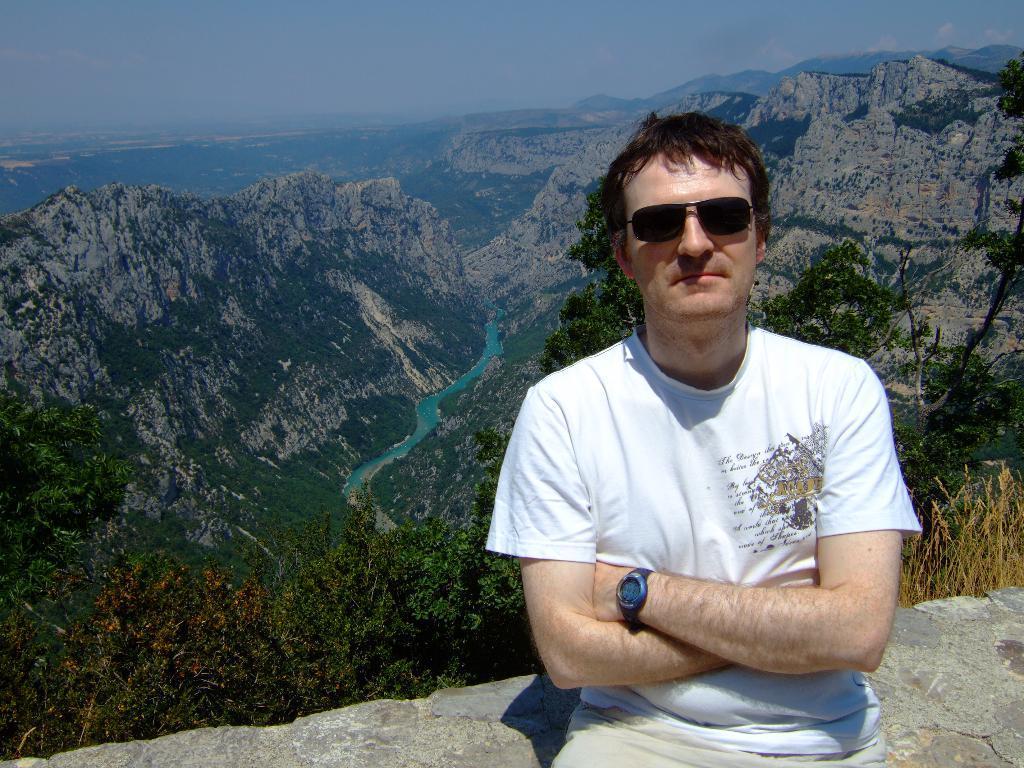Describe this image in one or two sentences. In the image I can see a person in white shirt and behind there are some mountains, trees, plants and water. 